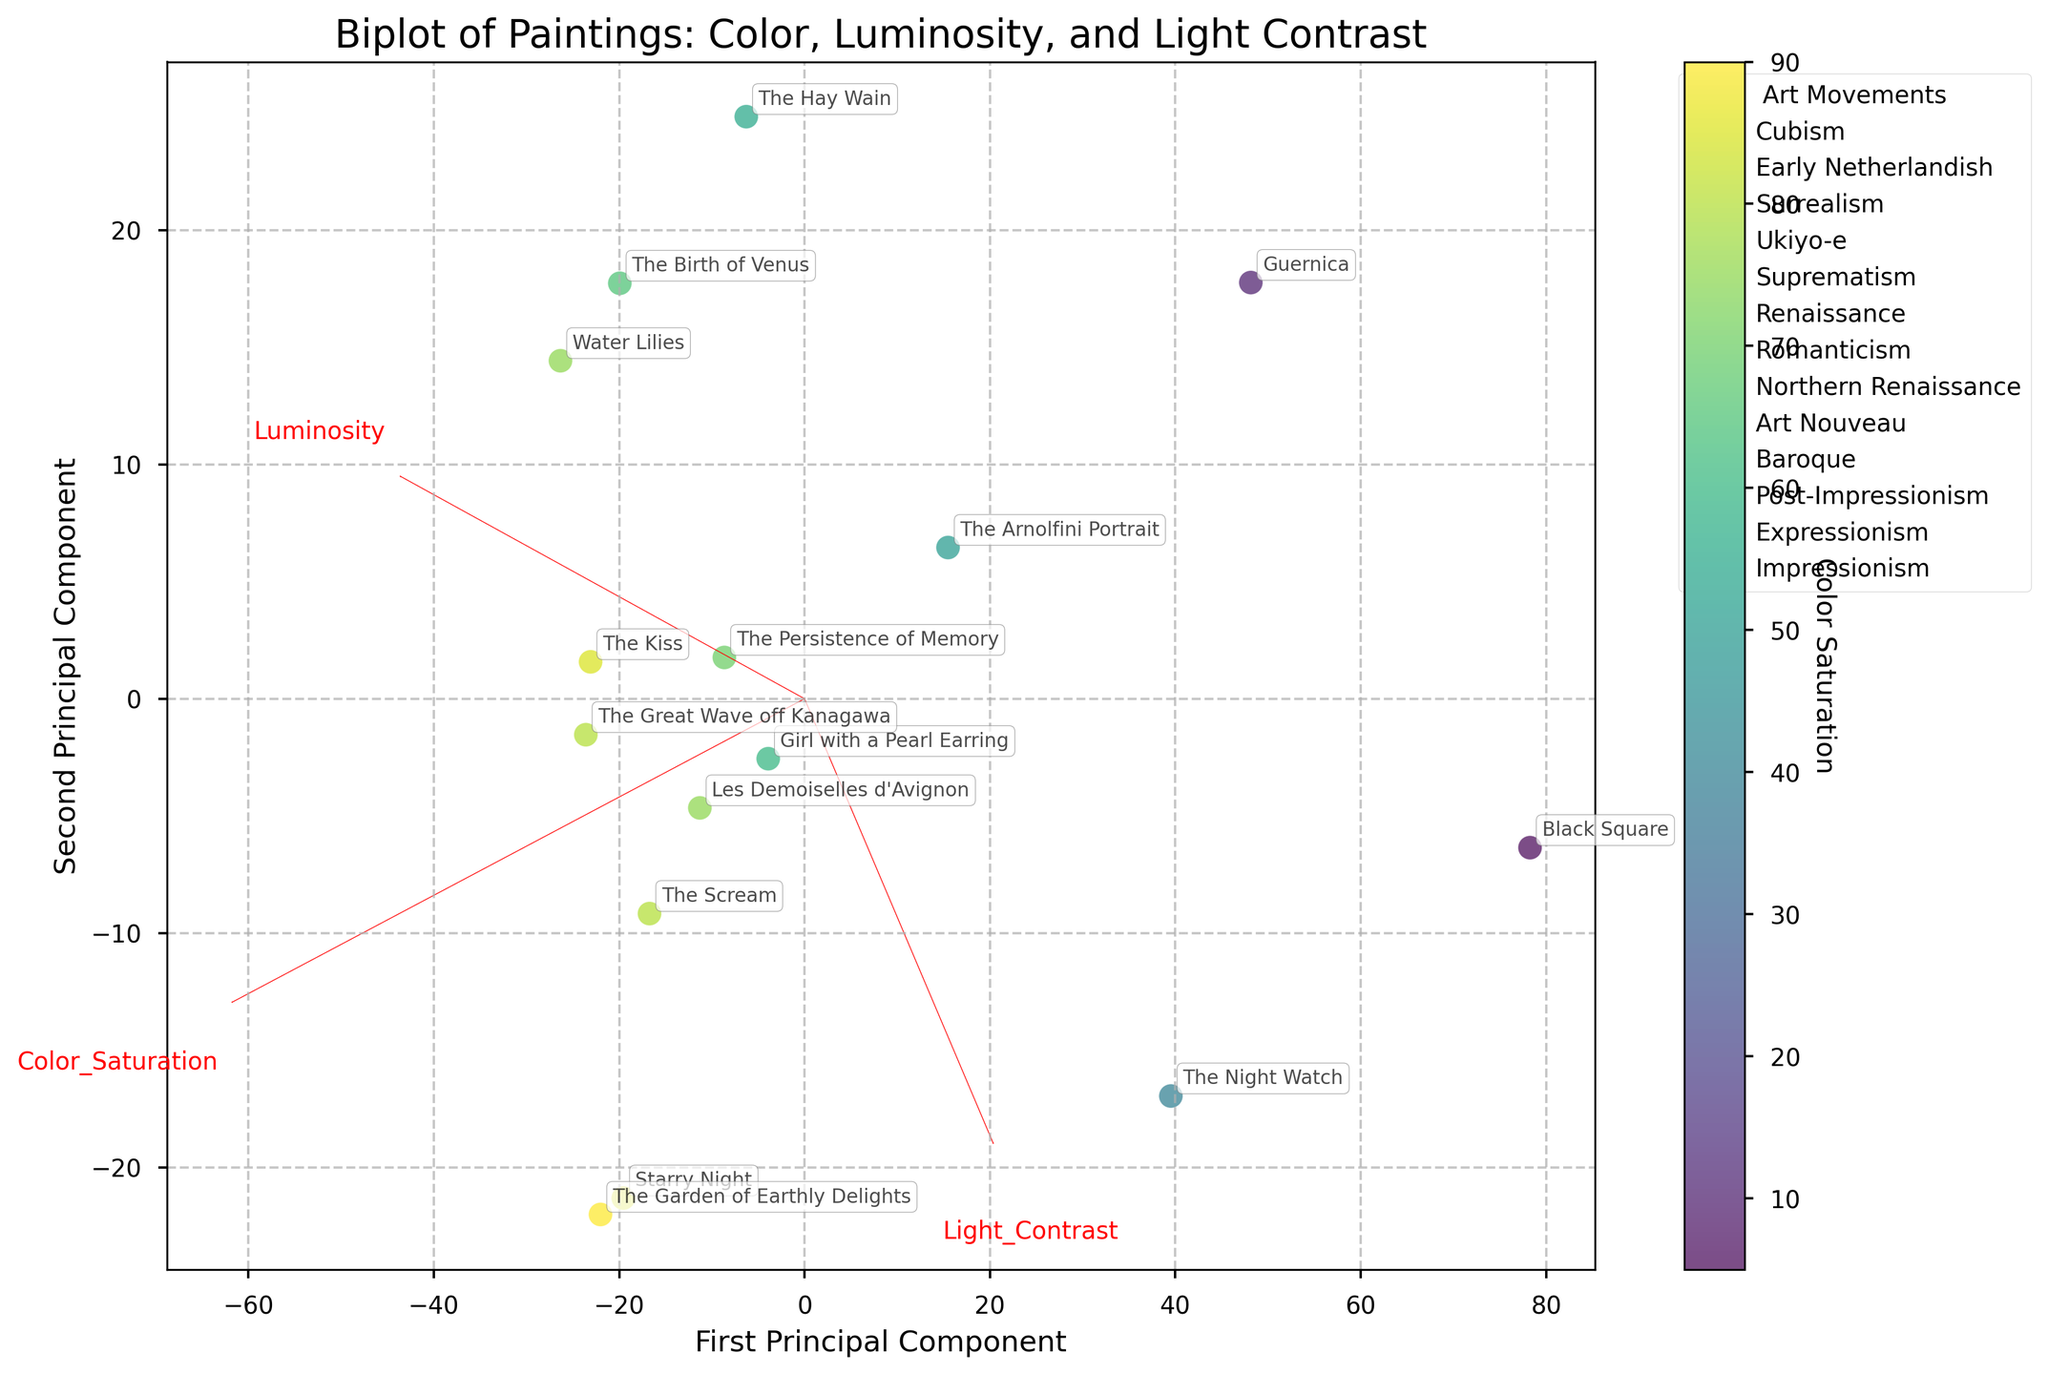What is the title of the plot? The title of the plot is clearly displayed at the top of the figure, and it summarizes the theme of the biplot.
Answer: Biplot of Paintings: Color, Luminosity, and Light Contrast What does the x-axis represent? The x-axis label provides the description of the first principal component, which is one of the two principal components used in the biplot.
Answer: First Principal Component Which art movement has the most paintings depicted in the plot? To determine the art movement with the most paintings, count the number of annotations for each movement label in the legend on the plot.
Answer: Baroque Which painting has the highest Color Saturation? Color Saturation is represented by the color intensity in the scatter plot. Among the annotations, identify the darkest colored point.
Answer: The Garden of Earthly Delights Which painting has the lowest Luminosity? Luminosity values can be inferred based on positions along the projected data axes, considering the directions of the feature vectors. The annotation closest to the lowest value on this axis should be identified.
Answer: Black Square How do the paintings from the Baroque movement compare in terms of Light Contrast? Locate the paintings associated with the Baroque movement and compare their positions relative to the Light Contrast vector direction and length in the biplot.
Answer: Girl with a Pearl Earring has lower Light Contrast than The Night Watch What's the average Luminosity of paintings in the Cubism movement? The paintings belonging to the Cubism movement are Guernica and Les Demoiselles d'Avignon. Use the positions on the Luminosity axis to determine their values and then compute the average. Values appear to be 50 and 60 respectively, so (50 + 60)/2 = 55.
Answer: 55 Which feature vector (Color Saturation, Luminosity, Light Contrast) seems to have the largest impact on the first principal component? Look for the feature vector arrow that aligns most closely with the direction of the first principal component axis.
Answer: Color Saturation Based on the biplot, which painting is most influenced by a high Light Contrast? Find the painting closest to the arrow representing Light Contrast.
Answer: The Night Watch What art movement does the painting with the highest Luminosity belong to? Identify the painting closest to the highest value on the Luminosity axis and refer to the legend to determine its movement.
Answer: Renaissance 